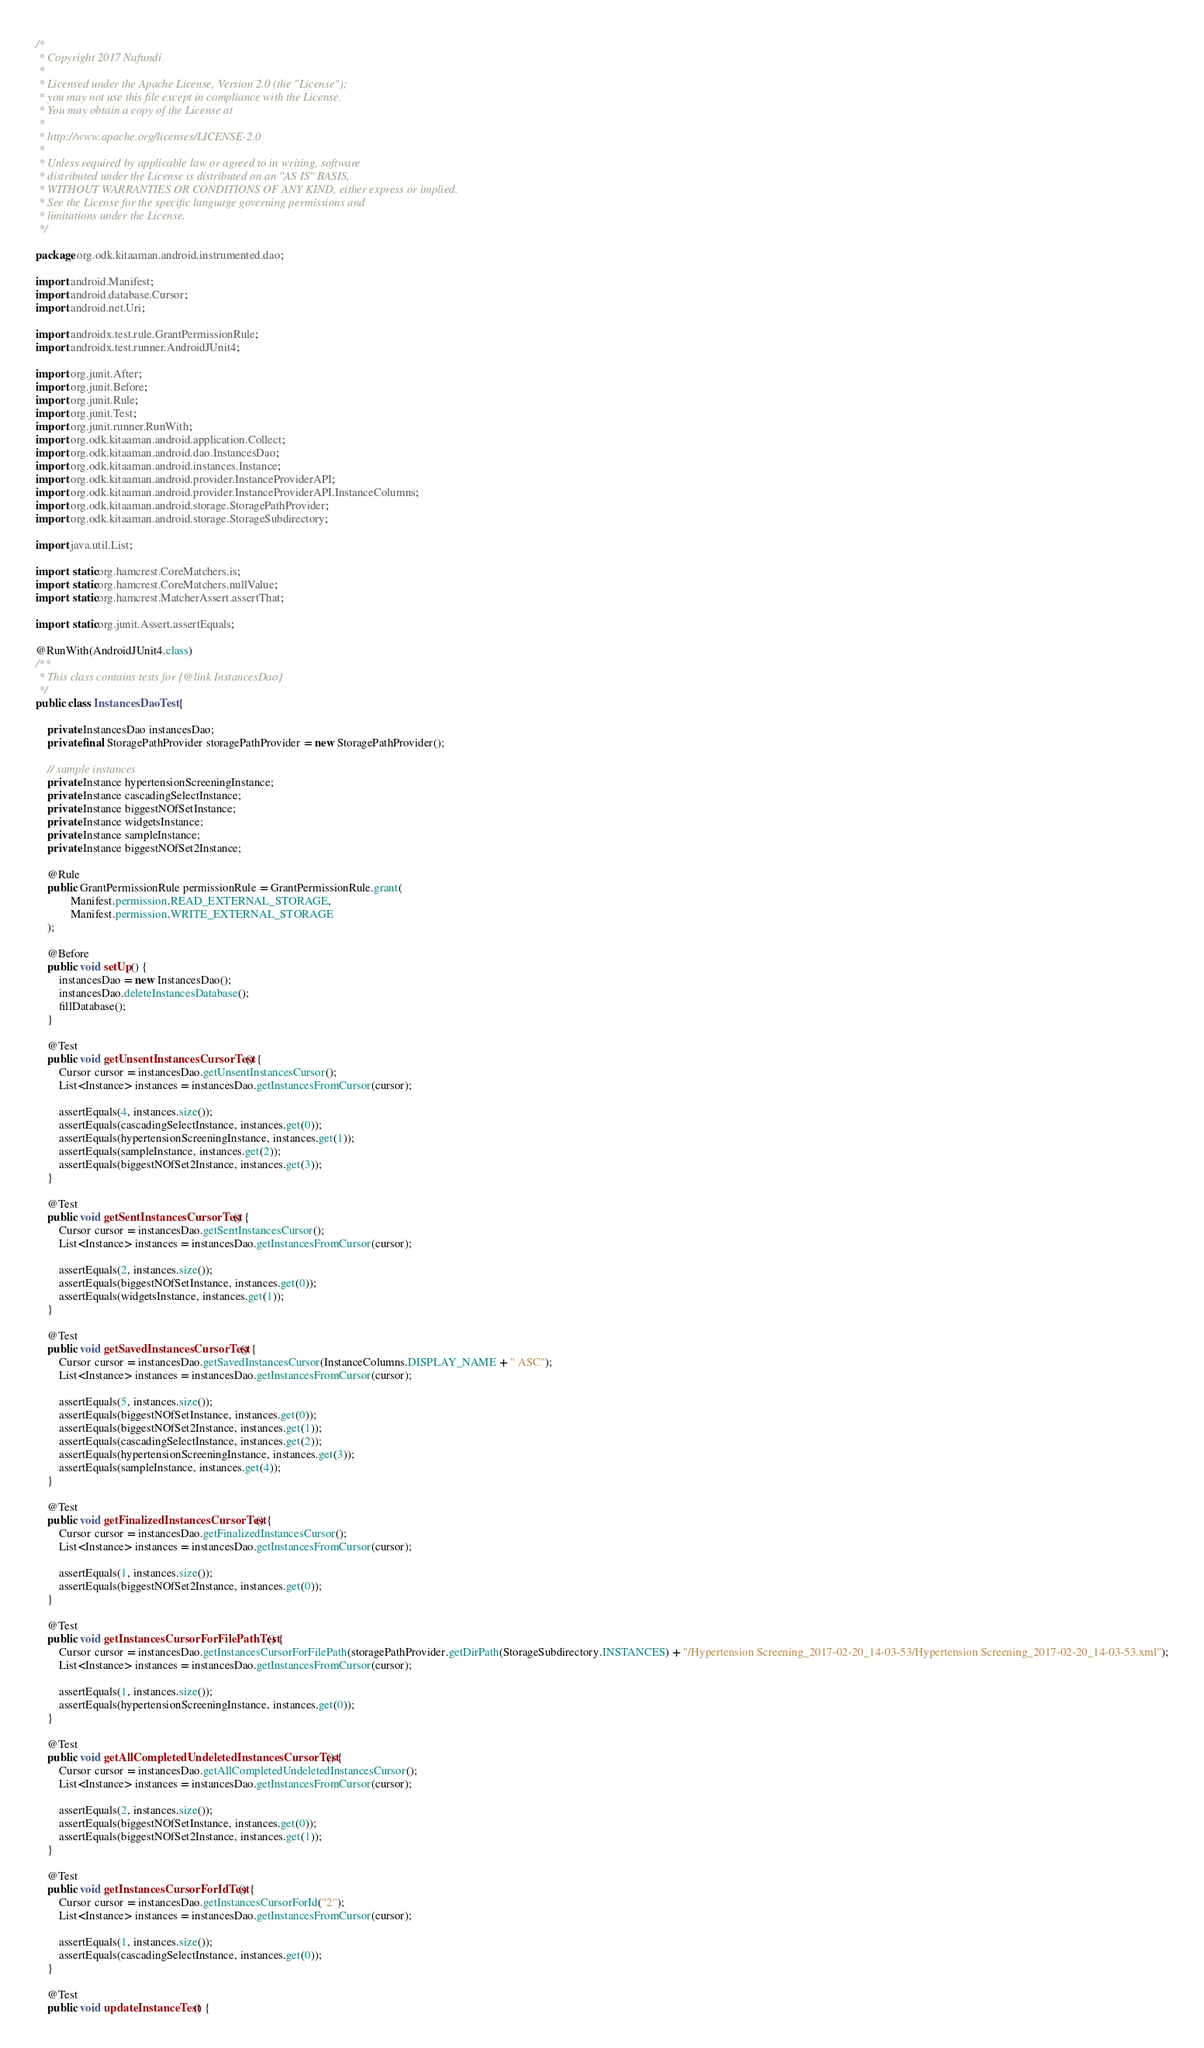Convert code to text. <code><loc_0><loc_0><loc_500><loc_500><_Java_>/*
 * Copyright 2017 Nafundi
 *
 * Licensed under the Apache License, Version 2.0 (the "License");
 * you may not use this file except in compliance with the License.
 * You may obtain a copy of the License at
 *
 * http://www.apache.org/licenses/LICENSE-2.0
 *
 * Unless required by applicable law or agreed to in writing, software
 * distributed under the License is distributed on an "AS IS" BASIS,
 * WITHOUT WARRANTIES OR CONDITIONS OF ANY KIND, either express or implied.
 * See the License for the specific language governing permissions and
 * limitations under the License.
 */

package org.odk.kitaaman.android.instrumented.dao;

import android.Manifest;
import android.database.Cursor;
import android.net.Uri;

import androidx.test.rule.GrantPermissionRule;
import androidx.test.runner.AndroidJUnit4;

import org.junit.After;
import org.junit.Before;
import org.junit.Rule;
import org.junit.Test;
import org.junit.runner.RunWith;
import org.odk.kitaaman.android.application.Collect;
import org.odk.kitaaman.android.dao.InstancesDao;
import org.odk.kitaaman.android.instances.Instance;
import org.odk.kitaaman.android.provider.InstanceProviderAPI;
import org.odk.kitaaman.android.provider.InstanceProviderAPI.InstanceColumns;
import org.odk.kitaaman.android.storage.StoragePathProvider;
import org.odk.kitaaman.android.storage.StorageSubdirectory;

import java.util.List;

import static org.hamcrest.CoreMatchers.is;
import static org.hamcrest.CoreMatchers.nullValue;
import static org.hamcrest.MatcherAssert.assertThat;

import static org.junit.Assert.assertEquals;

@RunWith(AndroidJUnit4.class)
/**
 * This class contains tests for {@link InstancesDao}
 */
public class InstancesDaoTest {

    private InstancesDao instancesDao;
    private final StoragePathProvider storagePathProvider = new StoragePathProvider();

    // sample instances
    private Instance hypertensionScreeningInstance;
    private Instance cascadingSelectInstance;
    private Instance biggestNOfSetInstance;
    private Instance widgetsInstance;
    private Instance sampleInstance;
    private Instance biggestNOfSet2Instance;

    @Rule
    public GrantPermissionRule permissionRule = GrantPermissionRule.grant(
            Manifest.permission.READ_EXTERNAL_STORAGE,
            Manifest.permission.WRITE_EXTERNAL_STORAGE
    );

    @Before
    public void setUp() {
        instancesDao = new InstancesDao();
        instancesDao.deleteInstancesDatabase();
        fillDatabase();
    }

    @Test
    public void getUnsentInstancesCursorTest() {
        Cursor cursor = instancesDao.getUnsentInstancesCursor();
        List<Instance> instances = instancesDao.getInstancesFromCursor(cursor);

        assertEquals(4, instances.size());
        assertEquals(cascadingSelectInstance, instances.get(0));
        assertEquals(hypertensionScreeningInstance, instances.get(1));
        assertEquals(sampleInstance, instances.get(2));
        assertEquals(biggestNOfSet2Instance, instances.get(3));
    }

    @Test
    public void getSentInstancesCursorTest() {
        Cursor cursor = instancesDao.getSentInstancesCursor();
        List<Instance> instances = instancesDao.getInstancesFromCursor(cursor);

        assertEquals(2, instances.size());
        assertEquals(biggestNOfSetInstance, instances.get(0));
        assertEquals(widgetsInstance, instances.get(1));
    }

    @Test
    public void getSavedInstancesCursorTest() {
        Cursor cursor = instancesDao.getSavedInstancesCursor(InstanceColumns.DISPLAY_NAME + " ASC");
        List<Instance> instances = instancesDao.getInstancesFromCursor(cursor);

        assertEquals(5, instances.size());
        assertEquals(biggestNOfSetInstance, instances.get(0));
        assertEquals(biggestNOfSet2Instance, instances.get(1));
        assertEquals(cascadingSelectInstance, instances.get(2));
        assertEquals(hypertensionScreeningInstance, instances.get(3));
        assertEquals(sampleInstance, instances.get(4));
    }

    @Test
    public void getFinalizedInstancesCursorTest() {
        Cursor cursor = instancesDao.getFinalizedInstancesCursor();
        List<Instance> instances = instancesDao.getInstancesFromCursor(cursor);

        assertEquals(1, instances.size());
        assertEquals(biggestNOfSet2Instance, instances.get(0));
    }

    @Test
    public void getInstancesCursorForFilePathTest() {
        Cursor cursor = instancesDao.getInstancesCursorForFilePath(storagePathProvider.getDirPath(StorageSubdirectory.INSTANCES) + "/Hypertension Screening_2017-02-20_14-03-53/Hypertension Screening_2017-02-20_14-03-53.xml");
        List<Instance> instances = instancesDao.getInstancesFromCursor(cursor);

        assertEquals(1, instances.size());
        assertEquals(hypertensionScreeningInstance, instances.get(0));
    }

    @Test
    public void getAllCompletedUndeletedInstancesCursorTest() {
        Cursor cursor = instancesDao.getAllCompletedUndeletedInstancesCursor();
        List<Instance> instances = instancesDao.getInstancesFromCursor(cursor);

        assertEquals(2, instances.size());
        assertEquals(biggestNOfSetInstance, instances.get(0));
        assertEquals(biggestNOfSet2Instance, instances.get(1));
    }

    @Test
    public void getInstancesCursorForIdTest() {
        Cursor cursor = instancesDao.getInstancesCursorForId("2");
        List<Instance> instances = instancesDao.getInstancesFromCursor(cursor);

        assertEquals(1, instances.size());
        assertEquals(cascadingSelectInstance, instances.get(0));
    }

    @Test
    public void updateInstanceTest() {</code> 